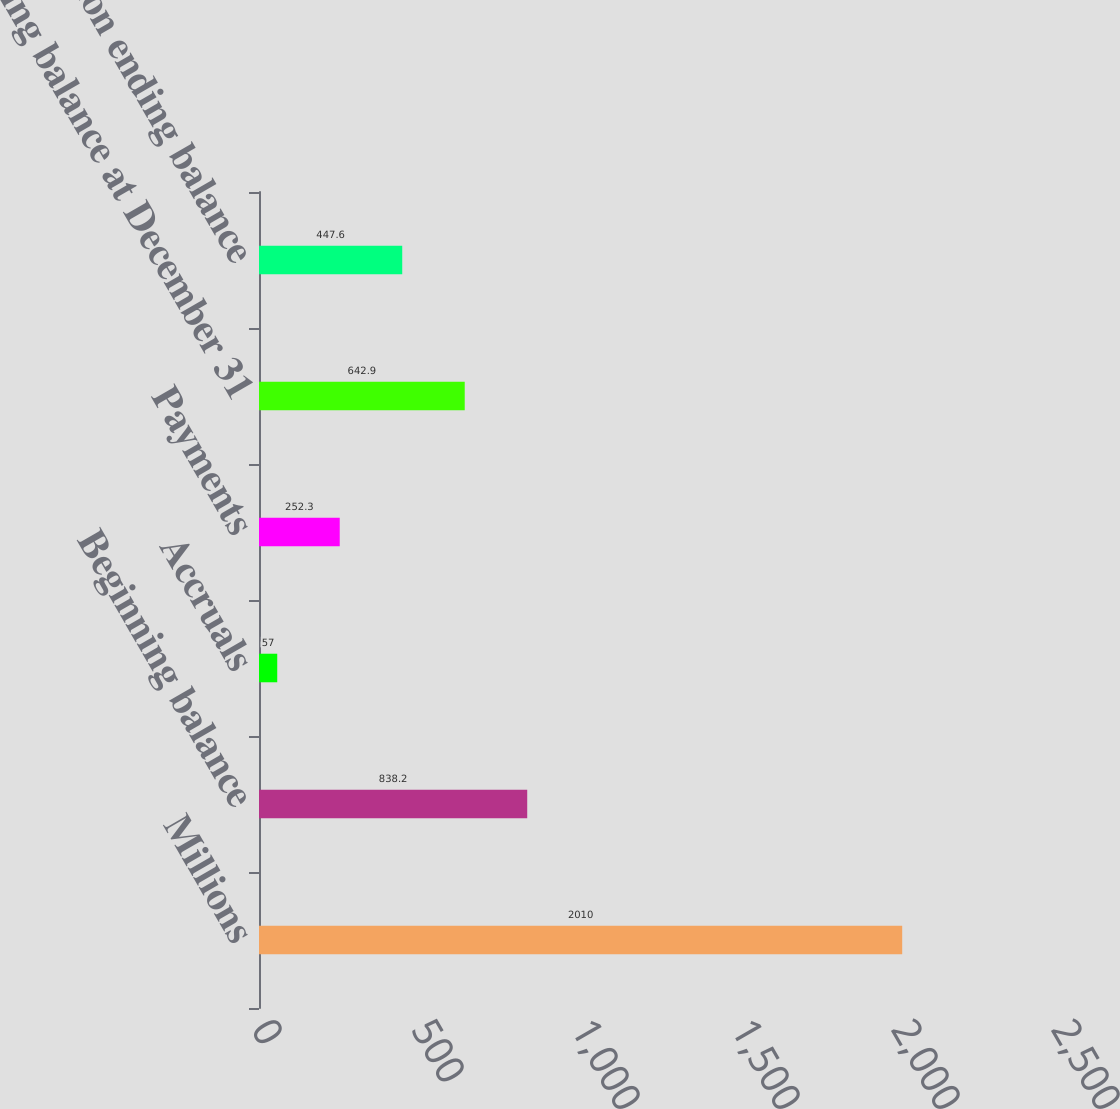Convert chart to OTSL. <chart><loc_0><loc_0><loc_500><loc_500><bar_chart><fcel>Millions<fcel>Beginning balance<fcel>Accruals<fcel>Payments<fcel>Ending balance at December 31<fcel>Current portion ending balance<nl><fcel>2010<fcel>838.2<fcel>57<fcel>252.3<fcel>642.9<fcel>447.6<nl></chart> 